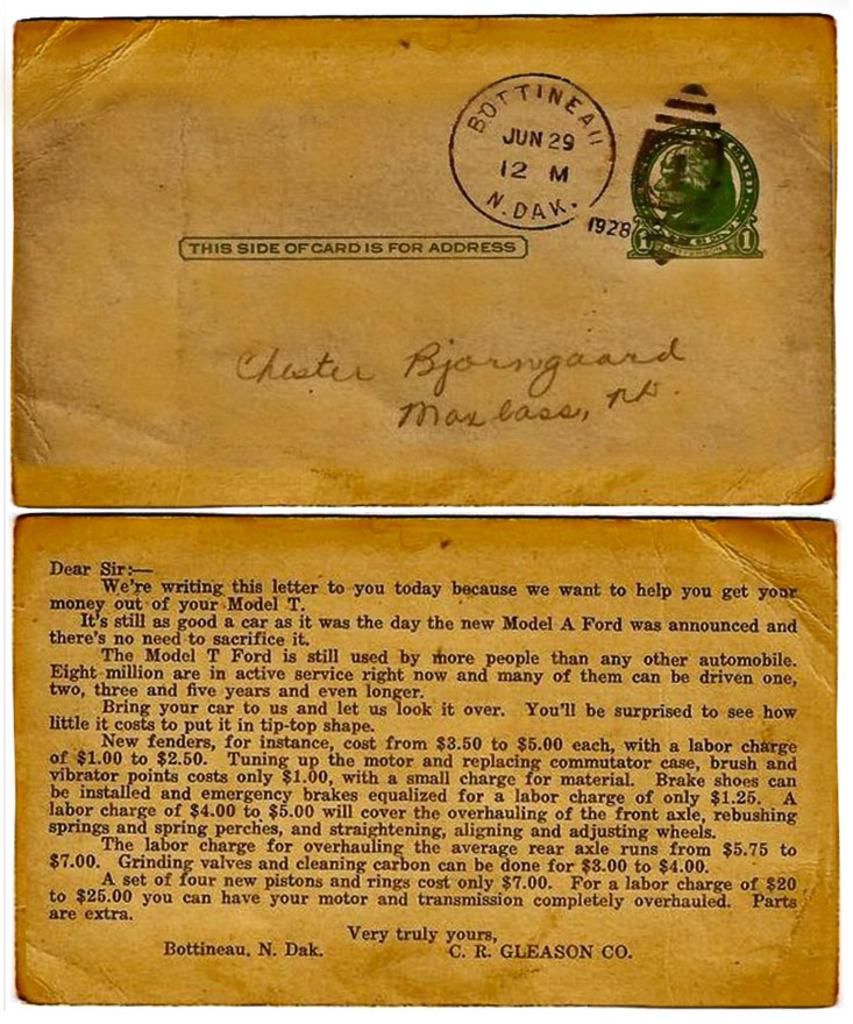<image>
Relay a brief, clear account of the picture shown. Postage Letter dated on June 29 1928 from Chester Bjorngard. 